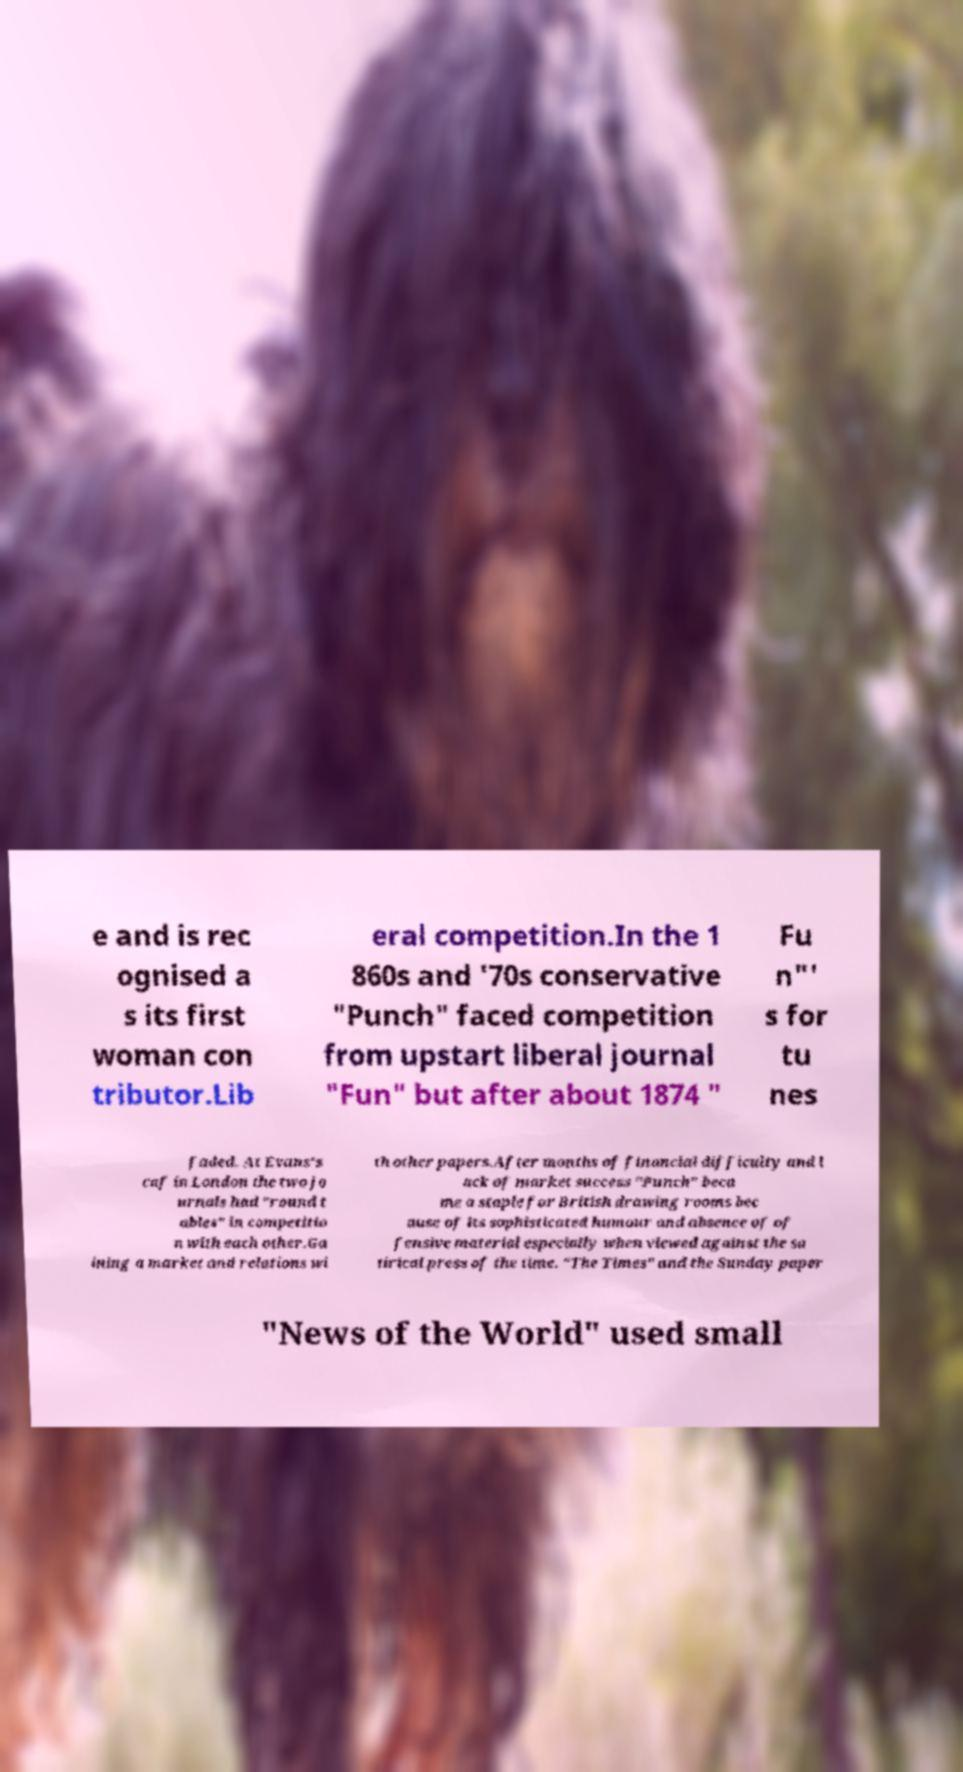Can you accurately transcribe the text from the provided image for me? e and is rec ognised a s its first woman con tributor.Lib eral competition.In the 1 860s and '70s conservative "Punch" faced competition from upstart liberal journal "Fun" but after about 1874 " Fu n"' s for tu nes faded. At Evans's caf in London the two jo urnals had "round t ables" in competitio n with each other.Ga ining a market and relations wi th other papers.After months of financial difficulty and l ack of market success "Punch" beca me a staple for British drawing rooms bec ause of its sophisticated humour and absence of of fensive material especially when viewed against the sa tirical press of the time. "The Times" and the Sunday paper "News of the World" used small 